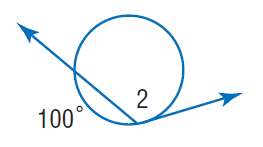Answer the mathemtical geometry problem and directly provide the correct option letter.
Question: Find m \angle 2.
Choices: A: 100 B: 130 C: 200 D: 300 B 